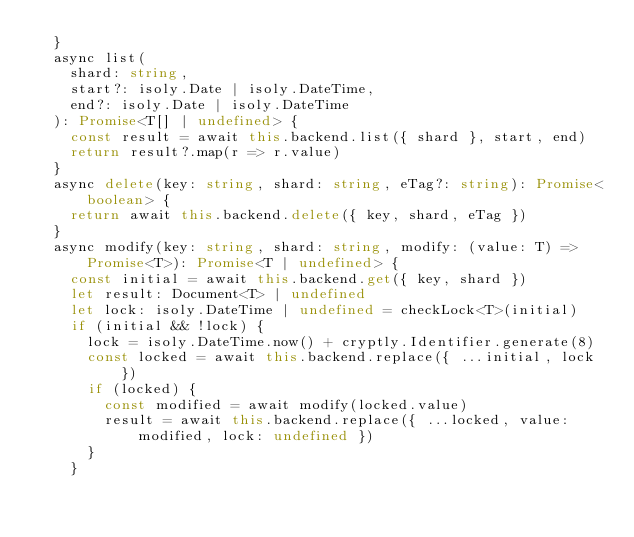Convert code to text. <code><loc_0><loc_0><loc_500><loc_500><_TypeScript_>	}
	async list(
		shard: string,
		start?: isoly.Date | isoly.DateTime,
		end?: isoly.Date | isoly.DateTime
	): Promise<T[] | undefined> {
		const result = await this.backend.list({ shard }, start, end)
		return result?.map(r => r.value)
	}
	async delete(key: string, shard: string, eTag?: string): Promise<boolean> {
		return await this.backend.delete({ key, shard, eTag })
	}
	async modify(key: string, shard: string, modify: (value: T) => Promise<T>): Promise<T | undefined> {
		const initial = await this.backend.get({ key, shard })
		let result: Document<T> | undefined
		let lock: isoly.DateTime | undefined = checkLock<T>(initial)
		if (initial && !lock) {
			lock = isoly.DateTime.now() + cryptly.Identifier.generate(8)
			const locked = await this.backend.replace({ ...initial, lock })
			if (locked) {
				const modified = await modify(locked.value)
				result = await this.backend.replace({ ...locked, value: modified, lock: undefined })
			}
		}</code> 